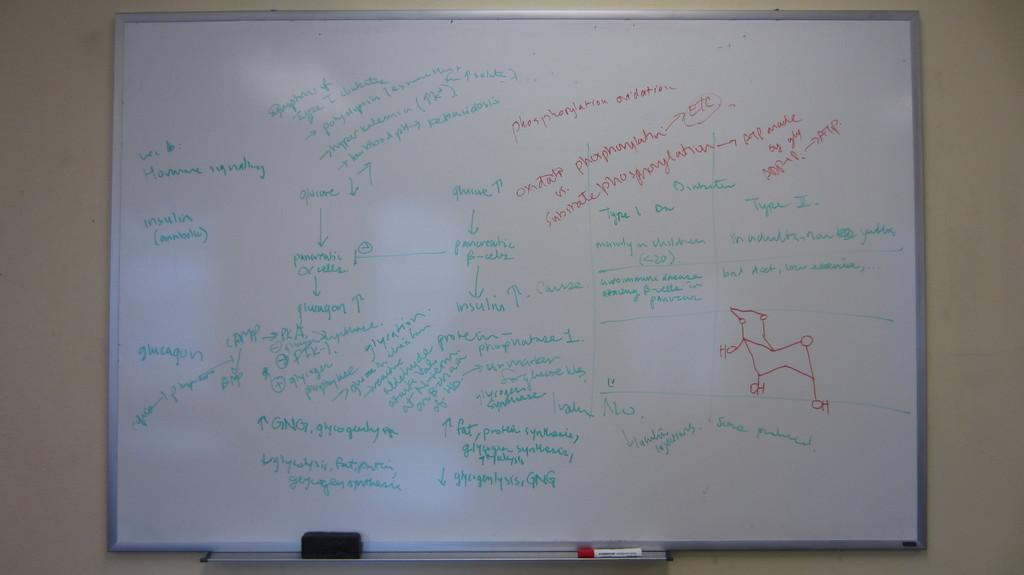What is on the wall in the image? There is a board on the wall in the image. What is on the platform in the image? There is a sketch on a platform in the image. What can be found on the board? The board contains text and drawings. How many ducks are sitting on the sofa in the image? There is no sofa or ducks present in the image. 